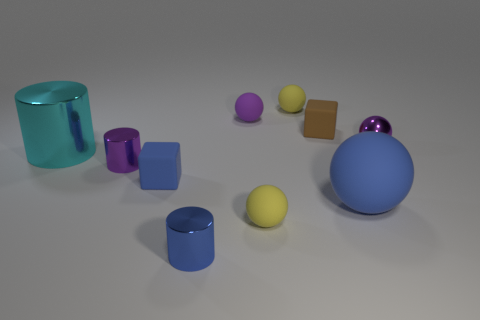What number of cylinders are either cyan objects or small red rubber objects?
Your answer should be very brief. 1. The rubber block that is in front of the small purple metal thing on the right side of the tiny blue cube that is on the left side of the small brown thing is what color?
Provide a succinct answer. Blue. How many other objects are the same size as the brown thing?
Your response must be concise. 7. There is another thing that is the same shape as the tiny blue rubber thing; what color is it?
Your response must be concise. Brown. There is a large sphere that is the same material as the brown cube; what color is it?
Your answer should be very brief. Blue. Are there an equal number of tiny purple balls that are on the left side of the big rubber sphere and metallic things?
Your answer should be compact. No. Does the rubber cube to the left of the brown thing have the same size as the tiny blue shiny object?
Provide a short and direct response. Yes. What is the color of the other rubber block that is the same size as the blue rubber cube?
Your answer should be compact. Brown. Are there any large matte things to the right of the purple thing on the right side of the tiny yellow ball behind the small brown matte object?
Provide a succinct answer. No. What is the large object right of the small brown cube made of?
Provide a succinct answer. Rubber. 